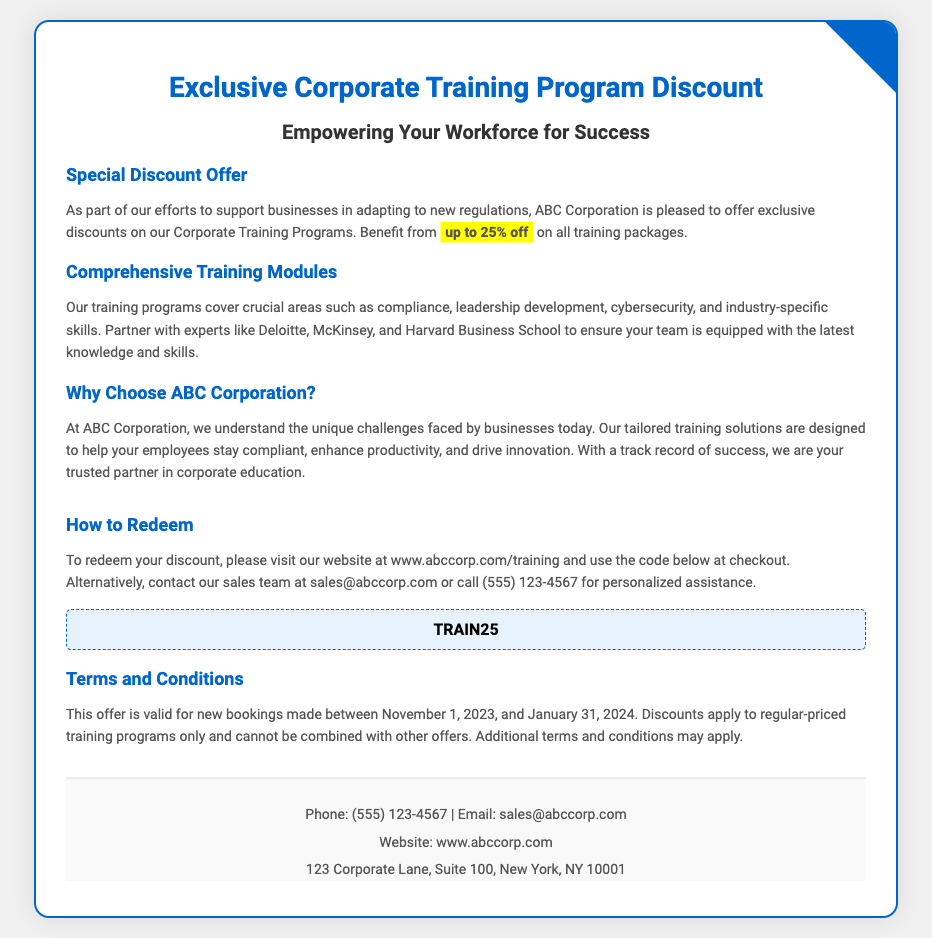What is the maximum discount offered? The maximum discount offered in the voucher is specified as "up to 25% off".
Answer: up to 25% off What is the discount code to redeem the offer? The voucher provides a specific code needed to redeem the discount, which is highlighted in a separate box.
Answer: TRAIN25 What is the validity period for the offer? The document states that the offer is valid for new bookings made between specific start and end dates.
Answer: November 1, 2023, and January 31, 2024 Who can you contact for assistance? The voucher includes contact information for personalized assistance, including a phone number and email address.
Answer: sales@abccorp.com What type of training programs does ABC Corporation offer? The document lists various areas covered by the training programs, highlighting the importance of compliance and development.
Answer: compliance, leadership development, cybersecurity, and industry-specific skills What is ABC Corporation's approach to training? The document discusses the corporation's understanding of business challenges and the design of tailored training solutions.
Answer: tailored training solutions How can customers redeem their discount? The document provides instructions for redemption that involve visiting the website and using a code.
Answer: visit our website at www.abccorp.com/training What is mentioned about other offers? The voucher states that the discount cannot be combined with other offers, indicating a specific limitation of the deal.
Answer: cannot be combined with other offers 